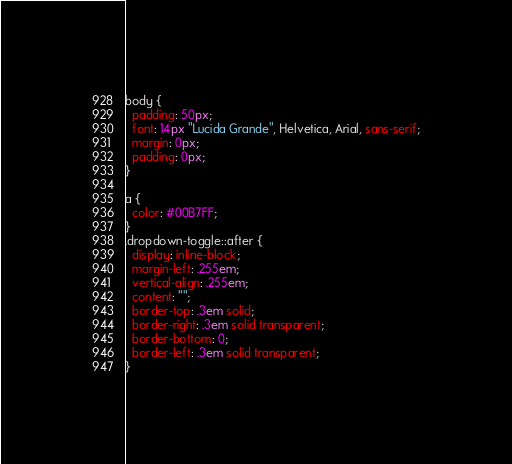<code> <loc_0><loc_0><loc_500><loc_500><_CSS_>body {
  padding: 50px;
  font: 14px "Lucida Grande", Helvetica, Arial, sans-serif;
  margin: 0px;
  padding: 0px;
}

a {
  color: #00B7FF;
}
.dropdown-toggle::after {
  display: inline-block;
  margin-left: .255em;
  vertical-align: .255em;
  content: "";
  border-top: .3em solid;
  border-right: .3em solid transparent;
  border-bottom: 0;
  border-left: .3em solid transparent;
}</code> 